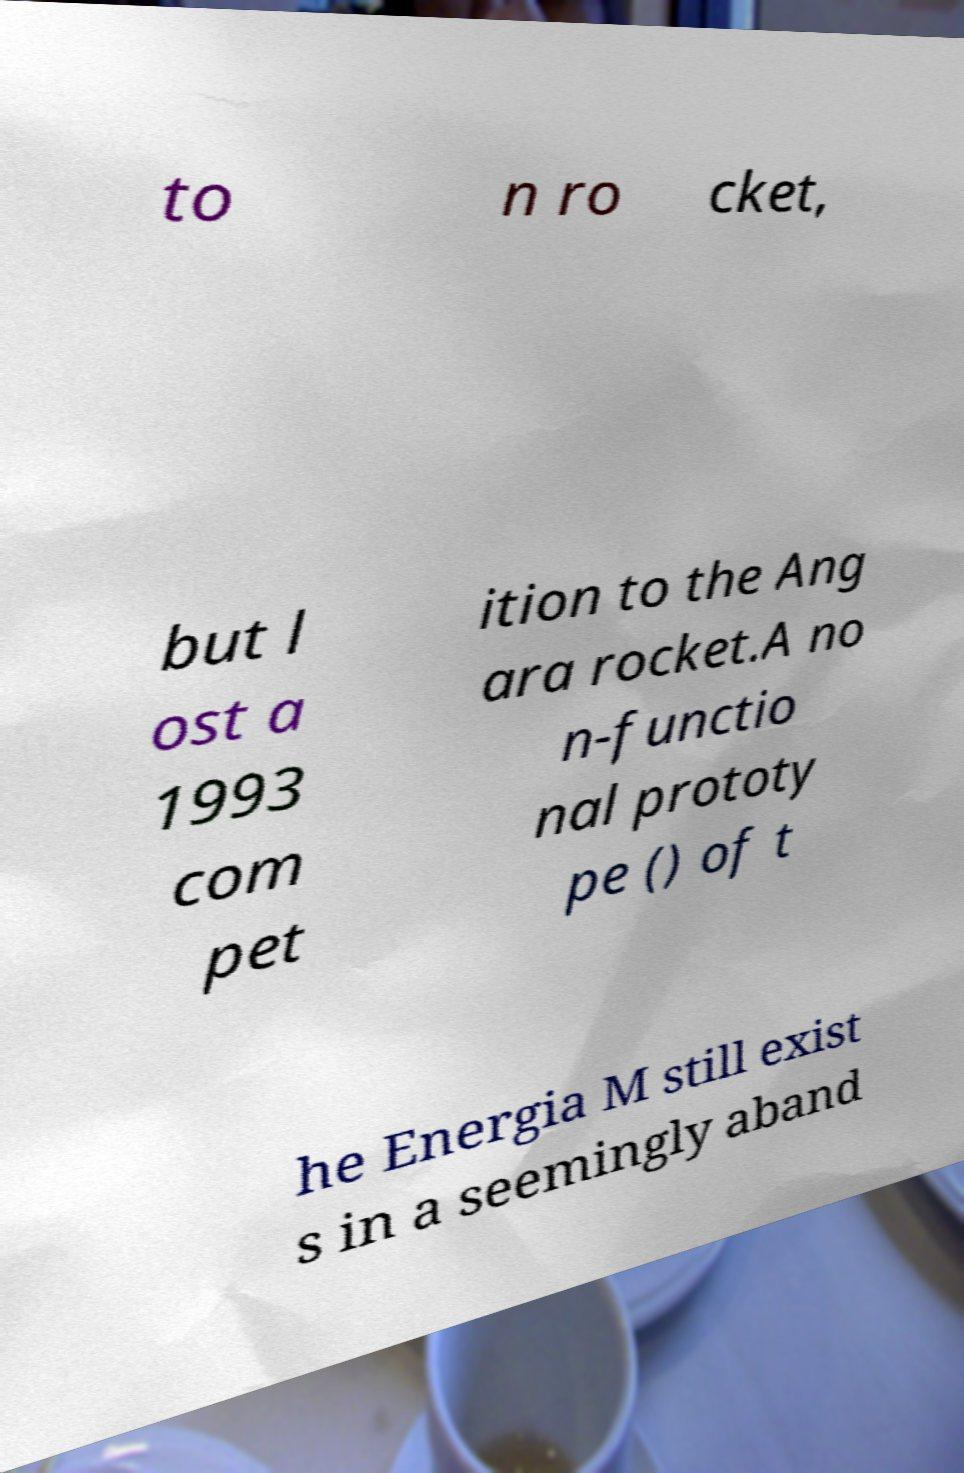Can you read and provide the text displayed in the image?This photo seems to have some interesting text. Can you extract and type it out for me? to n ro cket, but l ost a 1993 com pet ition to the Ang ara rocket.A no n-functio nal prototy pe () of t he Energia M still exist s in a seemingly aband 